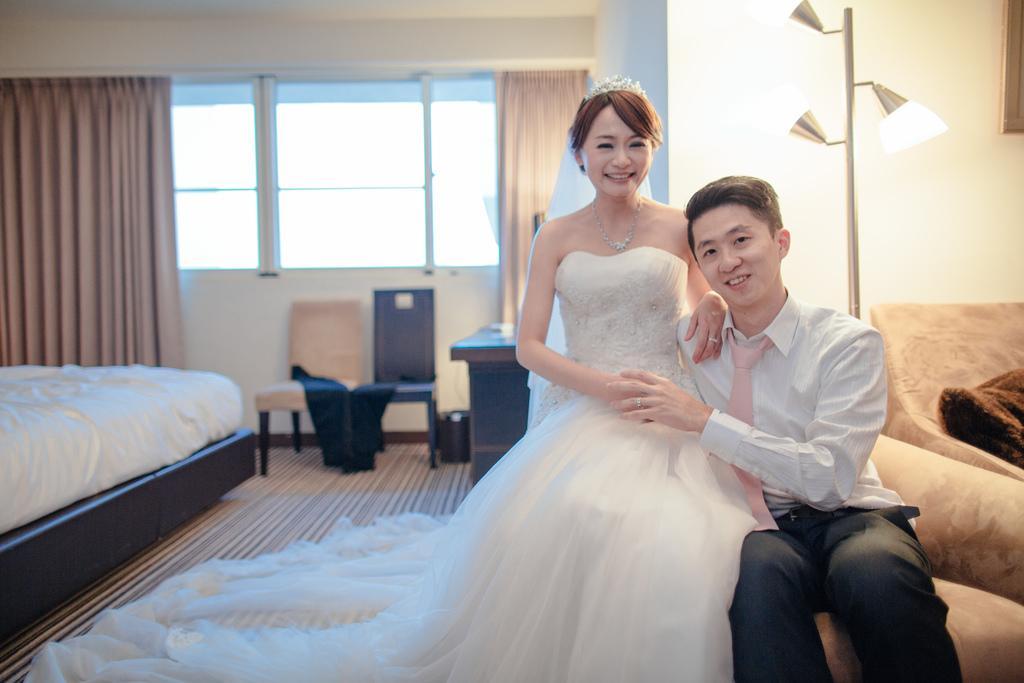Can you describe this image briefly? In the given image we can see a women and a man sitting next to each other. back of them there is a sofa and a light lamp. There is even a window, chair and bed. 